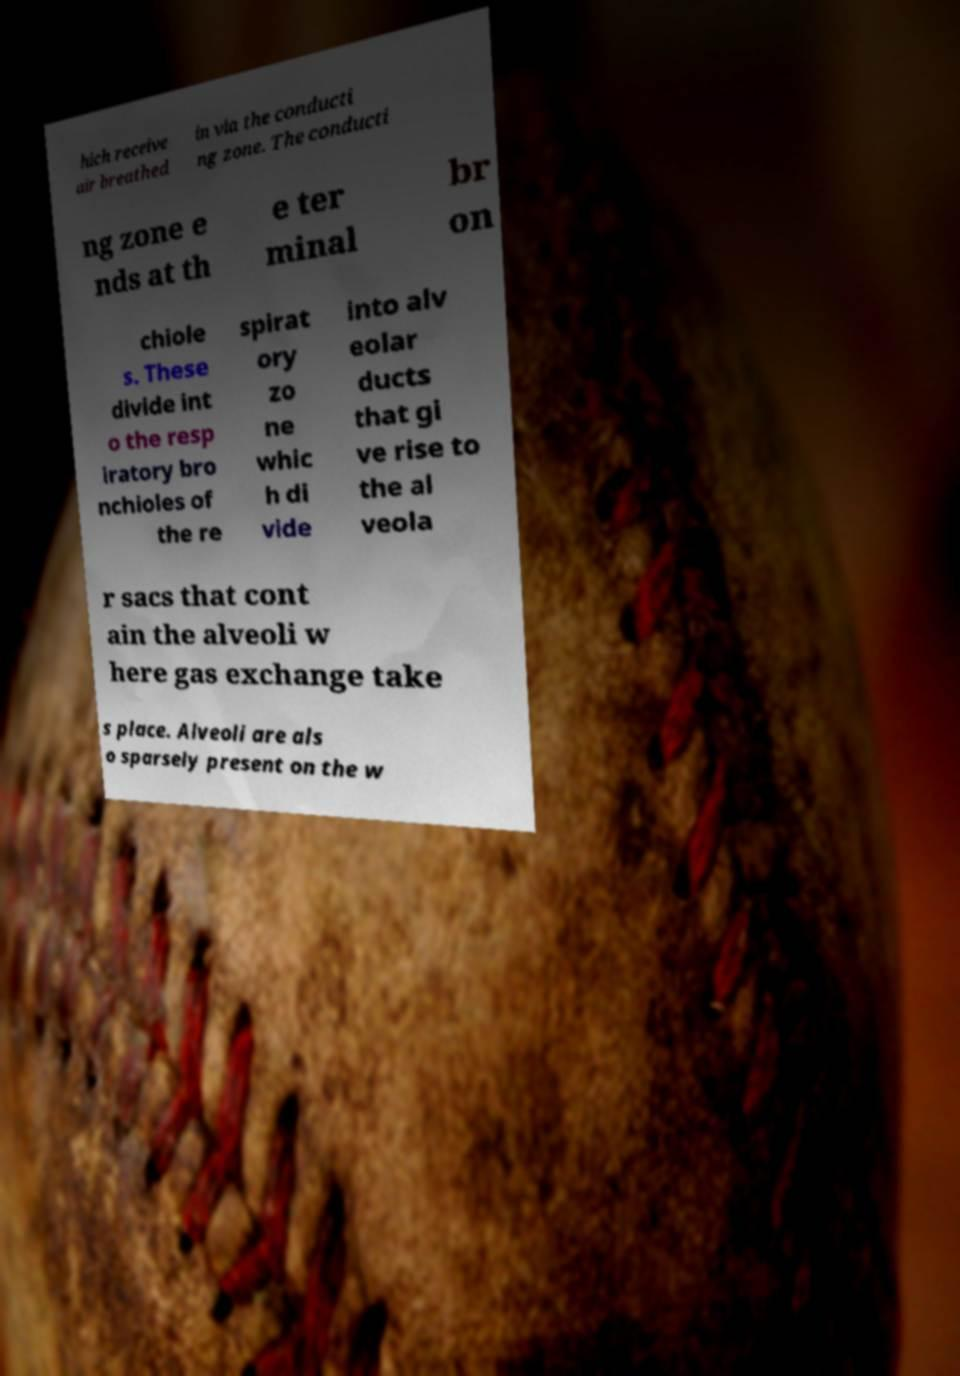Can you accurately transcribe the text from the provided image for me? hich receive air breathed in via the conducti ng zone. The conducti ng zone e nds at th e ter minal br on chiole s. These divide int o the resp iratory bro nchioles of the re spirat ory zo ne whic h di vide into alv eolar ducts that gi ve rise to the al veola r sacs that cont ain the alveoli w here gas exchange take s place. Alveoli are als o sparsely present on the w 